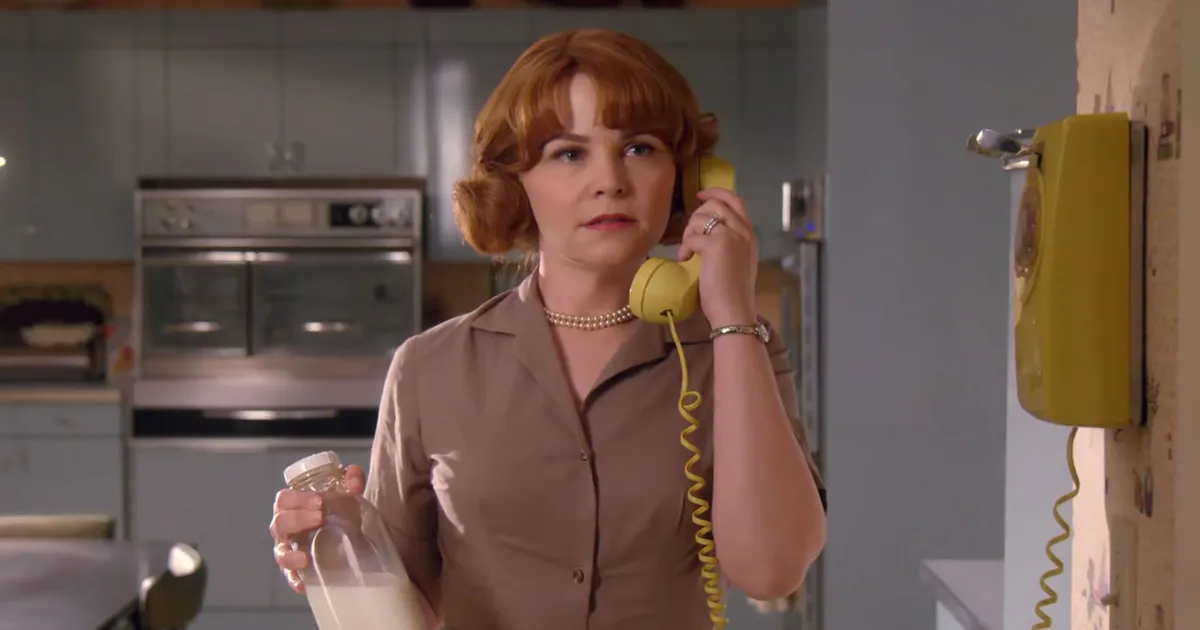Imagine a conversation taking place in this kitchen. What are they talking about? In this charming retro kitchen, Mary Margaret might be engaging in a heartfelt conversation with a close friend or family member. She could be discussing the daily happenings in their small town, sharing news about a recent community event or baking recipe, or perhaps seeking advice on a personal matter. The warm, nostalgic tone of the setting lends itself well to intimate, meaningful exchanges that were often a staple of mid-20th century life. What kind of recipe do you think she might be discussing? Given the vintage setting of the kitchen, Mary Margaret might be discussing a classic recipe passed down through generations, such as a homemade apple pie or a rich, creamy custard. The conversation could include tips on achieving the perfect flaky crust, the best types of apples to use, or the importance of adding just the right amount of nutmeg and cinnamon to enhance the flavor. She could also be reminiscing about how this recipe has been a family favorite for years, often enjoyed together during holidays or special gatherings. Now for a wild question: If this kitchen could talk, what stories would it tell? If this kitchen could talk, it would share countless tales of family milestones and cherished moments. It would recount the laughter and joy of holiday dinners, the aroma of freshly baked goods filling the air, and the comforting sound of morning coffee brewing. Stories of children racing through the house, eager for a taste of the homemade treats cooling on the counter, would come alive. The kitchen might even reveal secrets of whispered late-night conversations, the quiet moments spent by the window watching the world outside, and the timeless bonds forged over shared meals and memories. 